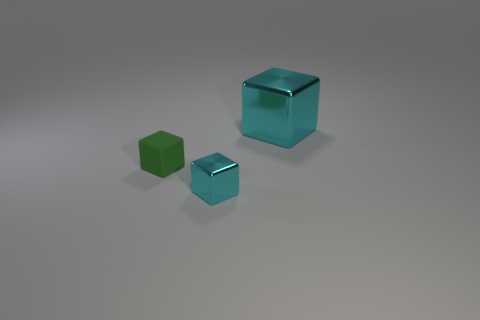Subtract all big blocks. How many blocks are left? 2 Add 3 large yellow shiny blocks. How many objects exist? 6 Subtract 2 cubes. How many cubes are left? 1 Subtract all cyan cubes. How many cubes are left? 1 Subtract all blue cylinders. How many green blocks are left? 1 Subtract all large red rubber things. Subtract all shiny blocks. How many objects are left? 1 Add 2 large metallic things. How many large metallic things are left? 3 Add 2 green rubber objects. How many green rubber objects exist? 3 Subtract 0 brown cylinders. How many objects are left? 3 Subtract all brown blocks. Subtract all yellow cylinders. How many blocks are left? 3 